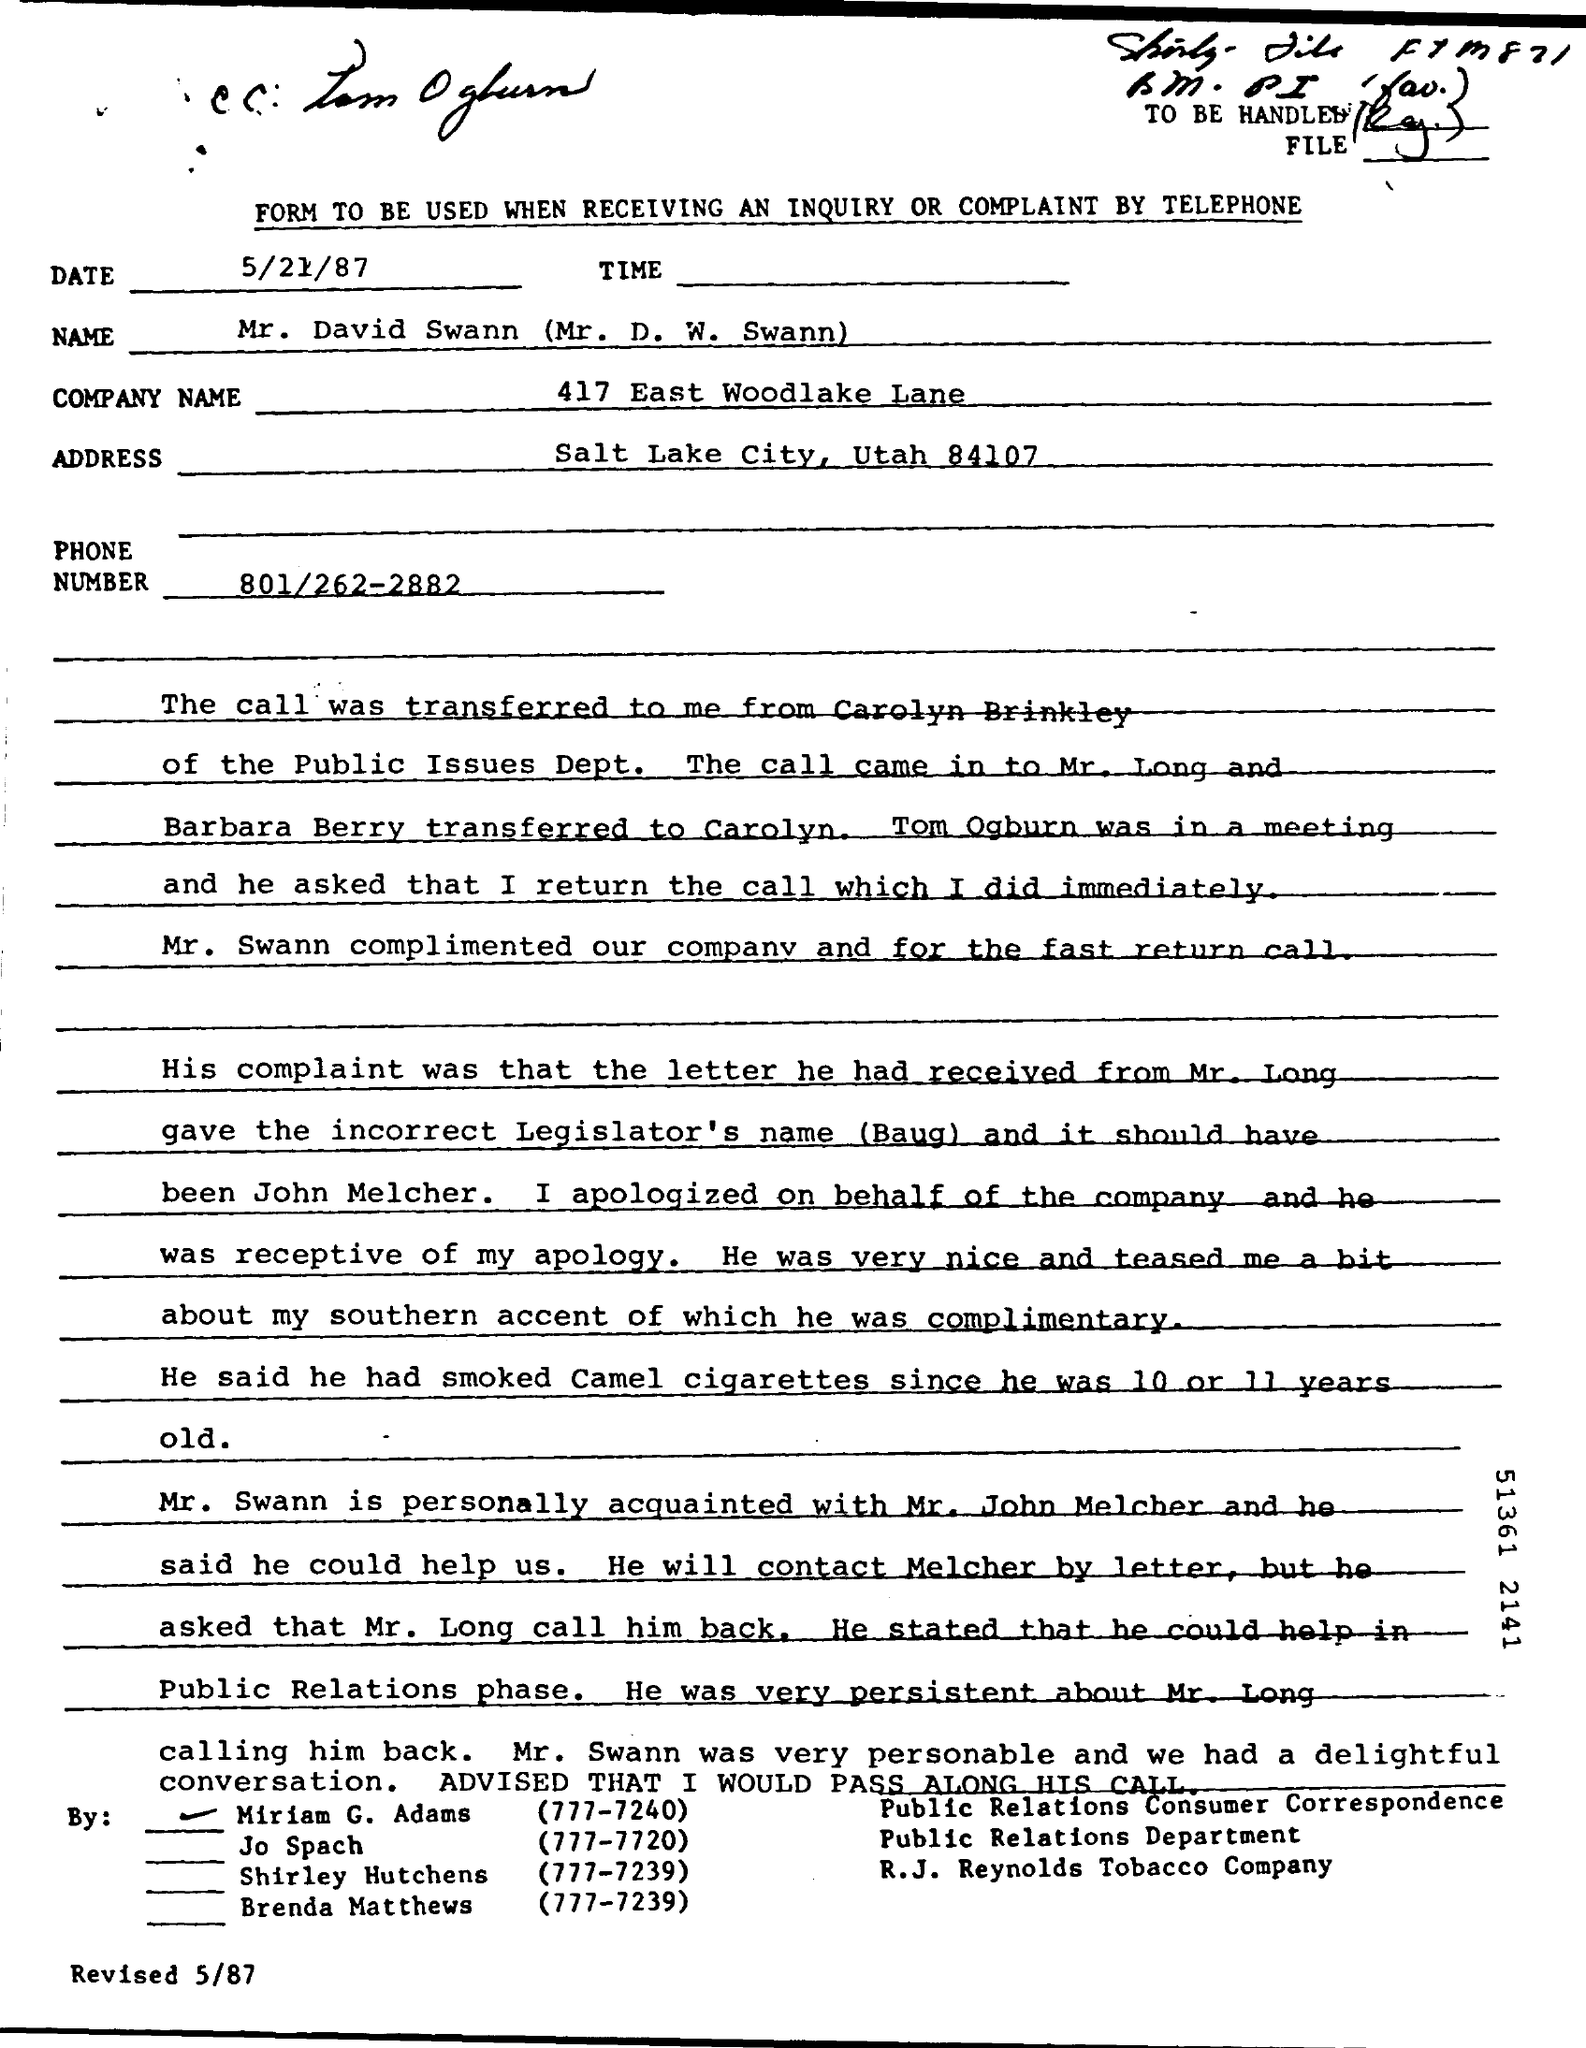When is the Memorandum dated on ?
Give a very brief answer. 5/21/87. What  is the Company Name?
Give a very brief answer. 417 East Woodlake Lane. What is the Phone Number ?
Ensure brevity in your answer.  801/262-2882. What is the Memorandum Address ?
Keep it short and to the point. Salt Lake City, Utah 84107. 